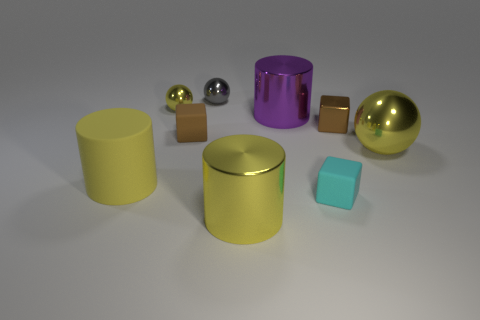How many yellow spheres must be subtracted to get 1 yellow spheres? 1 Subtract all small gray balls. How many balls are left? 2 Add 1 yellow shiny spheres. How many objects exist? 10 Subtract all brown cubes. How many cubes are left? 1 Subtract all gray cylinders. How many brown blocks are left? 2 Subtract 1 cylinders. How many cylinders are left? 2 Subtract all brown cubes. Subtract all yellow balls. How many cubes are left? 1 Add 7 small purple shiny cylinders. How many small purple shiny cylinders exist? 7 Subtract 0 blue spheres. How many objects are left? 9 Subtract all cylinders. How many objects are left? 6 